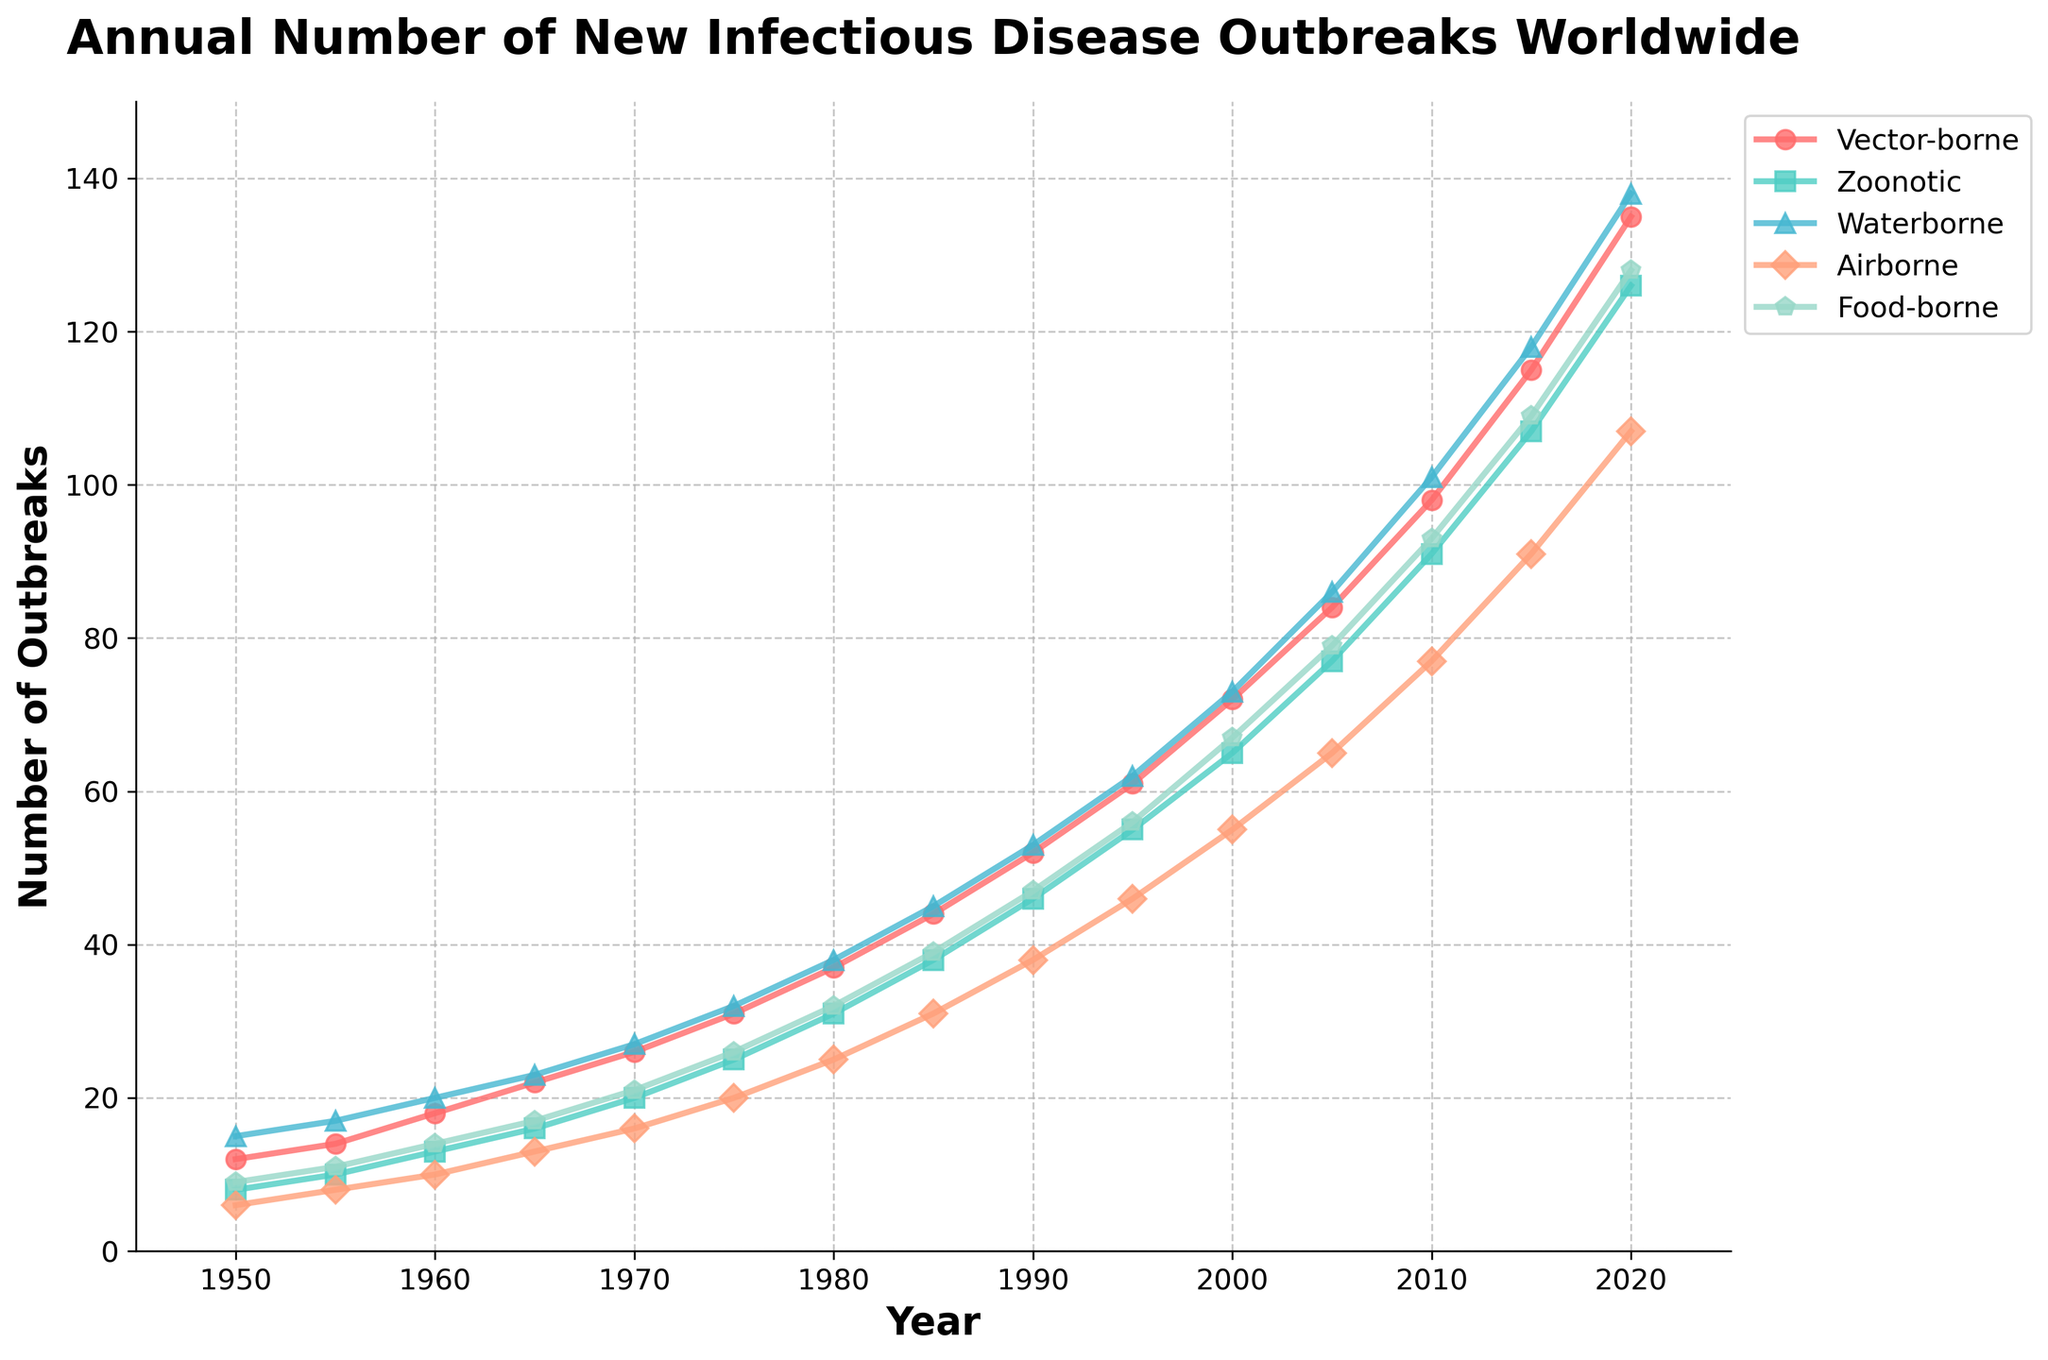What's the trend in the annual number of new vector-borne infectious disease outbreaks between 1950 and 2020? The red line representing vector-borne outbreaks shows a consistent upward trend from 1950 (with 12 outbreaks) to 2020 (with 135 outbreaks).
Answer: Upward trend Which type of infectious disease had the highest number of outbreaks in 2020? By looking at the endpoint in 2020, the green line representing waterborne outbreaks is the highest at 138 outbreaks.
Answer: Waterborne How many more zoonotic disease outbreaks were there in 2020 compared to 1980? In 2020, there were 126 zoonotic outbreaks while in 1980 there were 31. The difference is 126 - 31 = 95.
Answer: 95 What is the increase in waterborne disease outbreaks from 1950 to 2020? In 1950, there were 15 waterborne outbreaks, and in 2020 there were 138. The increase is 138 - 15 = 123.
Answer: 123 Which transmission type had the slowest growth rate in outbreaks from 1950 to 2020? Comparing all lines, the airborne (light salmon) shows the smallest increase from 6 outbreaks in 1950 to 107 outbreaks in 2020. This is calculated as 107 - 6 = 101, which is smaller than others.
Answer: Airborne Between which years did the food-borne outbreaks see the steepest increase? The steepest slope can be observed between 1980 (32 outbreaks) and 1985 (39 outbreaks), where the increase was 39 - 32 = 7. This visual steepness indicates the highest rate of change.
Answer: 1980-1985 What was the overall increase percentage in vector-borne disease outbreaks from 1950 to 2020? The percentage increase is calculated as ((135 - 12) / 12) * 100 = 1025%.
Answer: 1025% Which year had the closest number of airborne and zoonotic outbreaks? In 2005, airborne and zoonotic outbreaks were very close with airborne at 65 and zoonotic at 77, making it the year with smallest difference.
Answer: 2005 How do the trends of vector-borne and food-borne disease outbreaks compare? Both lines show an upward trend, but the vector-borne outbreaks (red line) increased more consistently and sharply compared to food-borne outbreaks.
Answer: Vector-borne increases more sharply 